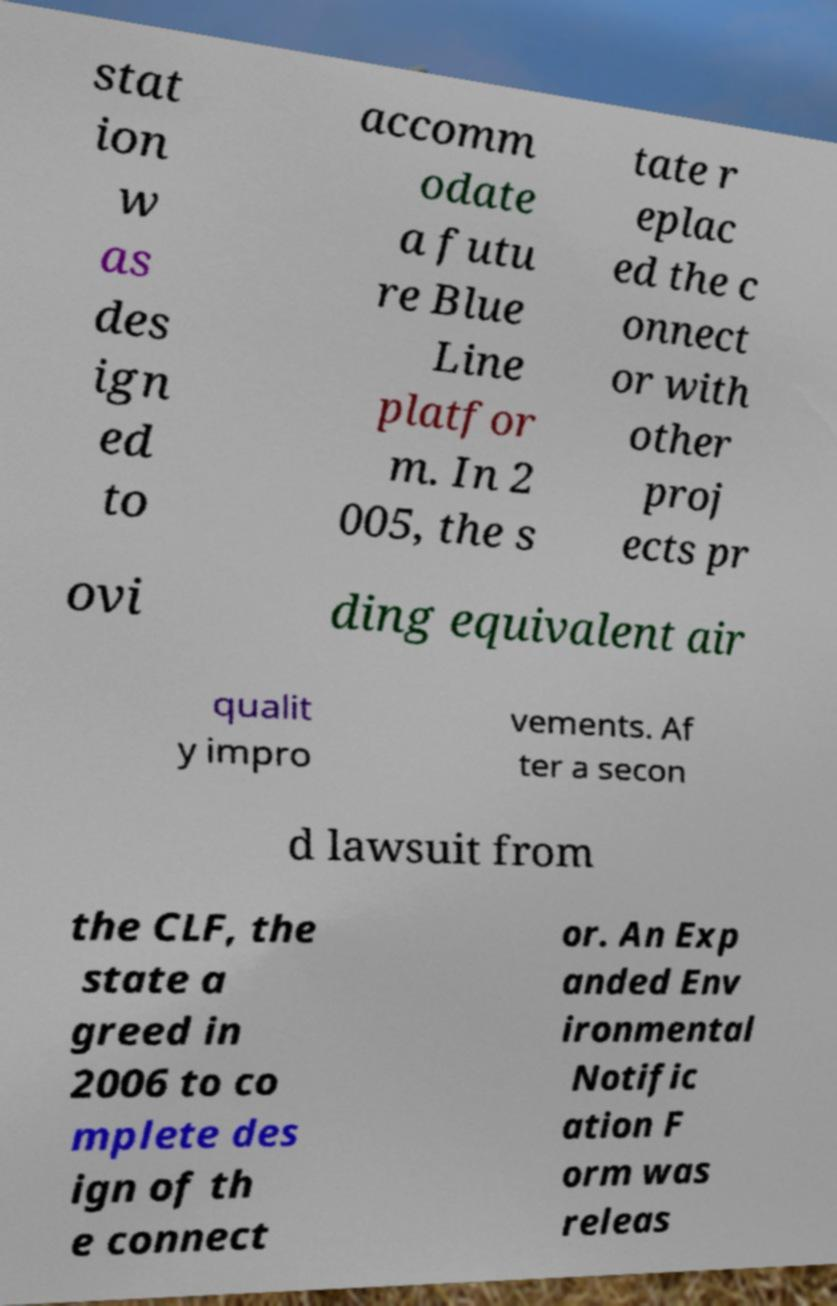I need the written content from this picture converted into text. Can you do that? stat ion w as des ign ed to accomm odate a futu re Blue Line platfor m. In 2 005, the s tate r eplac ed the c onnect or with other proj ects pr ovi ding equivalent air qualit y impro vements. Af ter a secon d lawsuit from the CLF, the state a greed in 2006 to co mplete des ign of th e connect or. An Exp anded Env ironmental Notific ation F orm was releas 